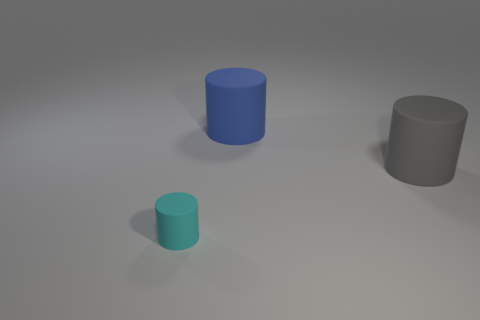Add 3 gray objects. How many objects exist? 6 Subtract all small blue rubber cylinders. Subtract all big blue cylinders. How many objects are left? 2 Add 2 matte cylinders. How many matte cylinders are left? 5 Add 2 large blue objects. How many large blue objects exist? 3 Subtract 0 yellow spheres. How many objects are left? 3 